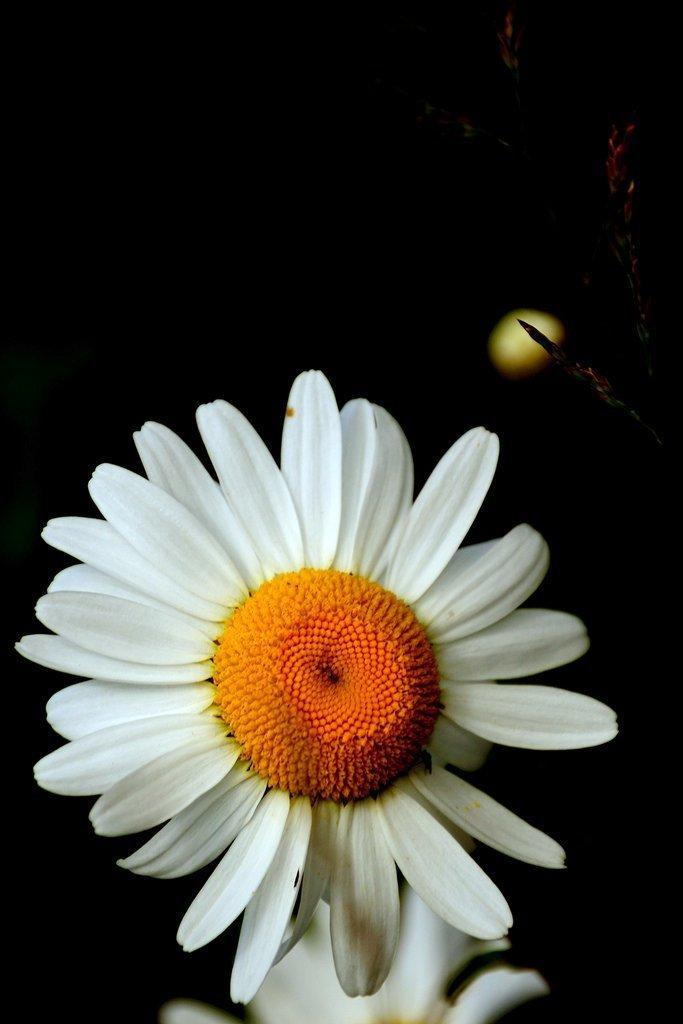How would you summarize this image in a sentence or two? In the picture I can see a white color flower and the background of the image is dark. The bottom of the image is slightly blurred, where I can see another flower. 